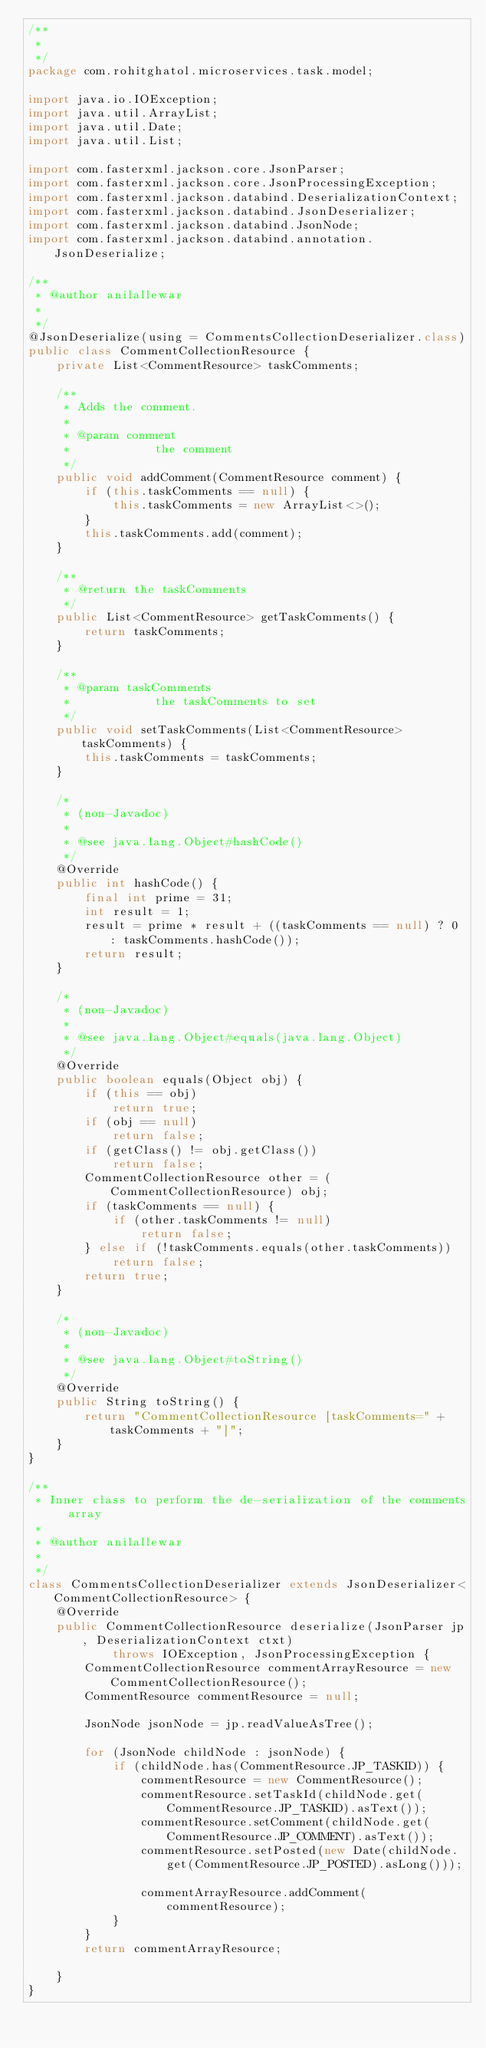<code> <loc_0><loc_0><loc_500><loc_500><_Java_>/**
 * 
 */
package com.rohitghatol.microservices.task.model;

import java.io.IOException;
import java.util.ArrayList;
import java.util.Date;
import java.util.List;

import com.fasterxml.jackson.core.JsonParser;
import com.fasterxml.jackson.core.JsonProcessingException;
import com.fasterxml.jackson.databind.DeserializationContext;
import com.fasterxml.jackson.databind.JsonDeserializer;
import com.fasterxml.jackson.databind.JsonNode;
import com.fasterxml.jackson.databind.annotation.JsonDeserialize;

/**
 * @author anilallewar
 *
 */
@JsonDeserialize(using = CommentsCollectionDeserializer.class)
public class CommentCollectionResource {
	private List<CommentResource> taskComments;

	/**
	 * Adds the comment.
	 *
	 * @param comment
	 *            the comment
	 */
	public void addComment(CommentResource comment) {
		if (this.taskComments == null) {
			this.taskComments = new ArrayList<>();
		}
		this.taskComments.add(comment);
	}

	/**
	 * @return the taskComments
	 */
	public List<CommentResource> getTaskComments() {
		return taskComments;
	}

	/**
	 * @param taskComments
	 *            the taskComments to set
	 */
	public void setTaskComments(List<CommentResource> taskComments) {
		this.taskComments = taskComments;
	}

	/*
	 * (non-Javadoc)
	 * 
	 * @see java.lang.Object#hashCode()
	 */
	@Override
	public int hashCode() {
		final int prime = 31;
		int result = 1;
		result = prime * result + ((taskComments == null) ? 0 : taskComments.hashCode());
		return result;
	}

	/*
	 * (non-Javadoc)
	 * 
	 * @see java.lang.Object#equals(java.lang.Object)
	 */
	@Override
	public boolean equals(Object obj) {
		if (this == obj)
			return true;
		if (obj == null)
			return false;
		if (getClass() != obj.getClass())
			return false;
		CommentCollectionResource other = (CommentCollectionResource) obj;
		if (taskComments == null) {
			if (other.taskComments != null)
				return false;
		} else if (!taskComments.equals(other.taskComments))
			return false;
		return true;
	}

	/*
	 * (non-Javadoc)
	 * 
	 * @see java.lang.Object#toString()
	 */
	@Override
	public String toString() {
		return "CommentCollectionResource [taskComments=" + taskComments + "]";
	}
}

/**
 * Inner class to perform the de-serialization of the comments array
 * 
 * @author anilallewar
 *
 */
class CommentsCollectionDeserializer extends JsonDeserializer<CommentCollectionResource> {
	@Override
	public CommentCollectionResource deserialize(JsonParser jp, DeserializationContext ctxt)
			throws IOException, JsonProcessingException {
		CommentCollectionResource commentArrayResource = new CommentCollectionResource();
		CommentResource commentResource = null;

		JsonNode jsonNode = jp.readValueAsTree();

		for (JsonNode childNode : jsonNode) {
			if (childNode.has(CommentResource.JP_TASKID)) {
				commentResource = new CommentResource();
				commentResource.setTaskId(childNode.get(CommentResource.JP_TASKID).asText());
				commentResource.setComment(childNode.get(CommentResource.JP_COMMENT).asText());
				commentResource.setPosted(new Date(childNode.get(CommentResource.JP_POSTED).asLong()));

				commentArrayResource.addComment(commentResource);
			}
		}
		return commentArrayResource;

	}
}</code> 